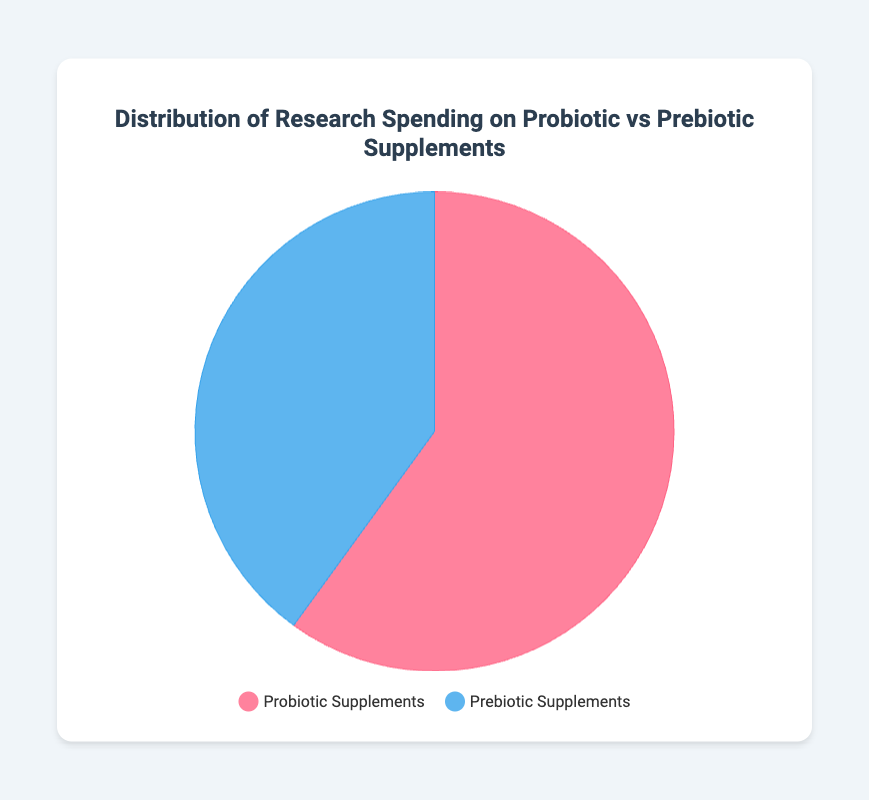What is the total spending on probiotic and prebiotic supplements? To find the total spending, sum the amounts allocated for both categories. Probiotics received $60,000,000 and prebiotics received $40,000,000. Thus, the total spending is $60,000,000 + $40,000,000 = $100,000,000.
Answer: $100,000,000 What percentage of the total research spending is allocated to probiotic supplements? First, find the total spending, which is $100,000,000. Then calculate the percentage allocated to probiotics: ($60,000,000 / $100,000,000) * 100 = 60%.
Answer: 60% Which category has received more research funding, probiotics or prebiotics? Compare the amounts allocated to each category. Probiotic supplements received $60,000,000, which is more than the $40,000,000 allocated to prebiotic supplements.
Answer: Probiotic supplements By how much does the research spending on probiotic supplements exceed that of prebiotic supplements? Subtract the amount allocated to prebiotic supplements from the amount allocated to probiotic supplements: $60,000,000 - $40,000,000 = $20,000,000.
Answer: $20,000,000 How are the funds distributed visually in the pie chart? The pie chart is divided into two segments with the larger segment representing probiotic supplements in red, and the smaller segment representing prebiotic supplements in blue, proportional to their respective amounts.
Answer: Probiotics: red, Prebiotics: blue What color represents prebiotic supplements in the pie chart? In the pie chart, the prebiotic supplements are represented by the blue segment.
Answer: Blue Which institutions are involved in the research on probiotic supplements? The key researchers or institutions involved in probiotic supplement research are Harvard University, University of California, and John Hopkins University.
Answer: Harvard University, University of California, John Hopkins University What is the difference in spending between the two categories as a percentage of the total spending? The difference in spending between probiotics and prebiotics is $20,000,000. To find this as a percentage of total spending: ($20,000,000 / $100,000,000) * 100 = 20%.
Answer: 20% What is the combined research spending on supplements? Sum the amounts allocated to both probiotic and prebiotic supplements: $60,000,000 + $40,000,000 = $100,000,000.
Answer: $100,000,000 